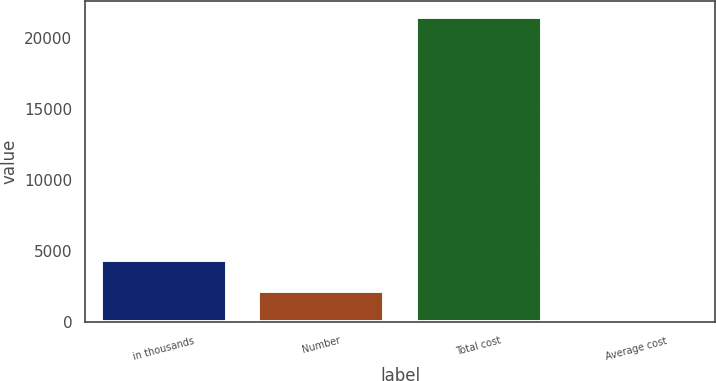Convert chart to OTSL. <chart><loc_0><loc_0><loc_500><loc_500><bar_chart><fcel>in thousands<fcel>Number<fcel>Total cost<fcel>Average cost<nl><fcel>4370.35<fcel>2232.27<fcel>21475<fcel>94.19<nl></chart> 